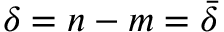Convert formula to latex. <formula><loc_0><loc_0><loc_500><loc_500>\delta = n - m = \bar { \delta }</formula> 